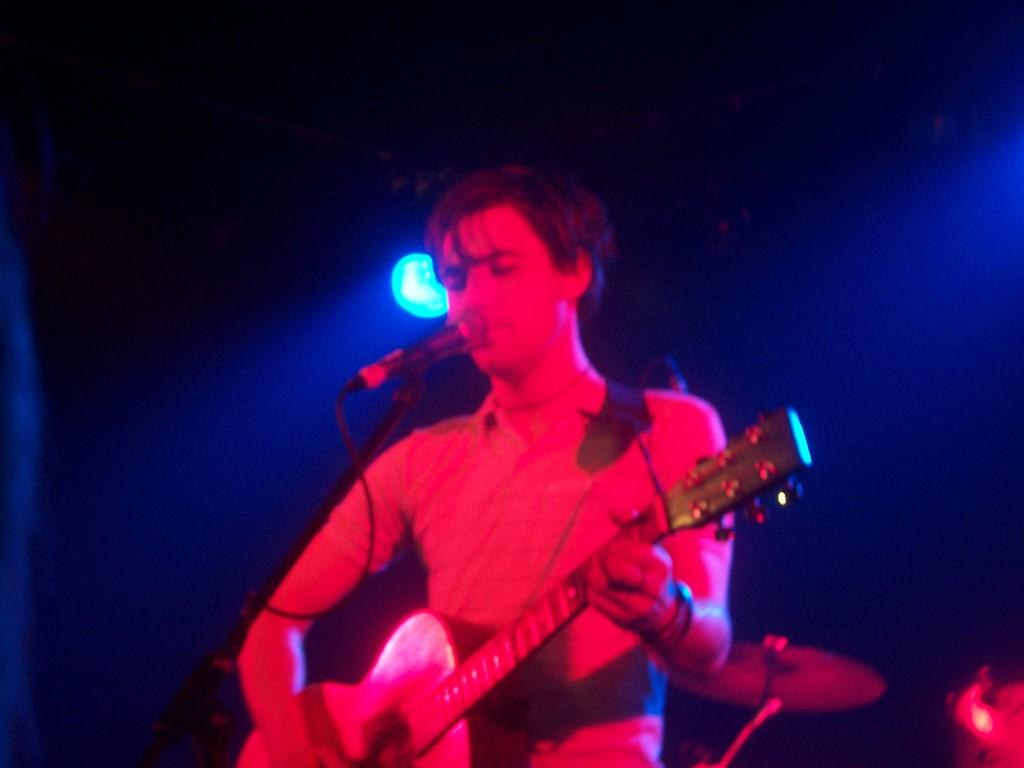What is the man in the image doing? The man is playing a guitar in the image. Is the man using any equipment while playing the guitar? Yes, the man is using a microphone while playing the guitar. How many babies are on the boat in the image? There are no babies or boats present in the image; it features a man playing a guitar and using a microphone. 